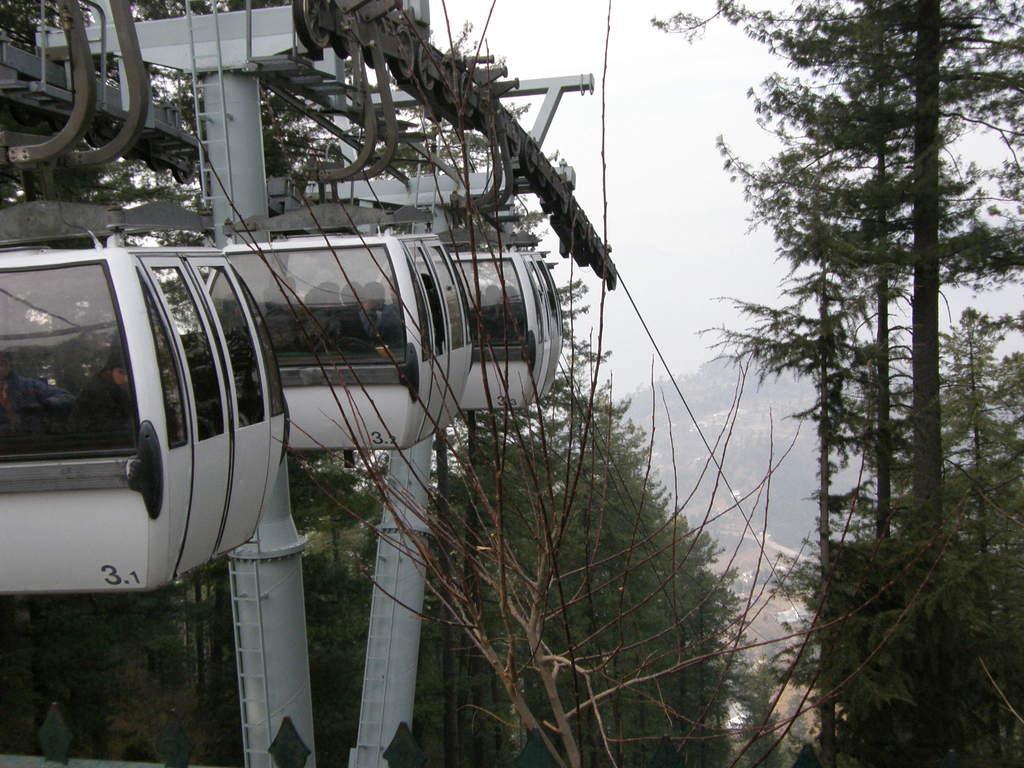In one or two sentences, can you explain what this image depicts? In this picture we can see cable cars and trees. Here we can see few persons inside the cable cars. In the background there is sky. 